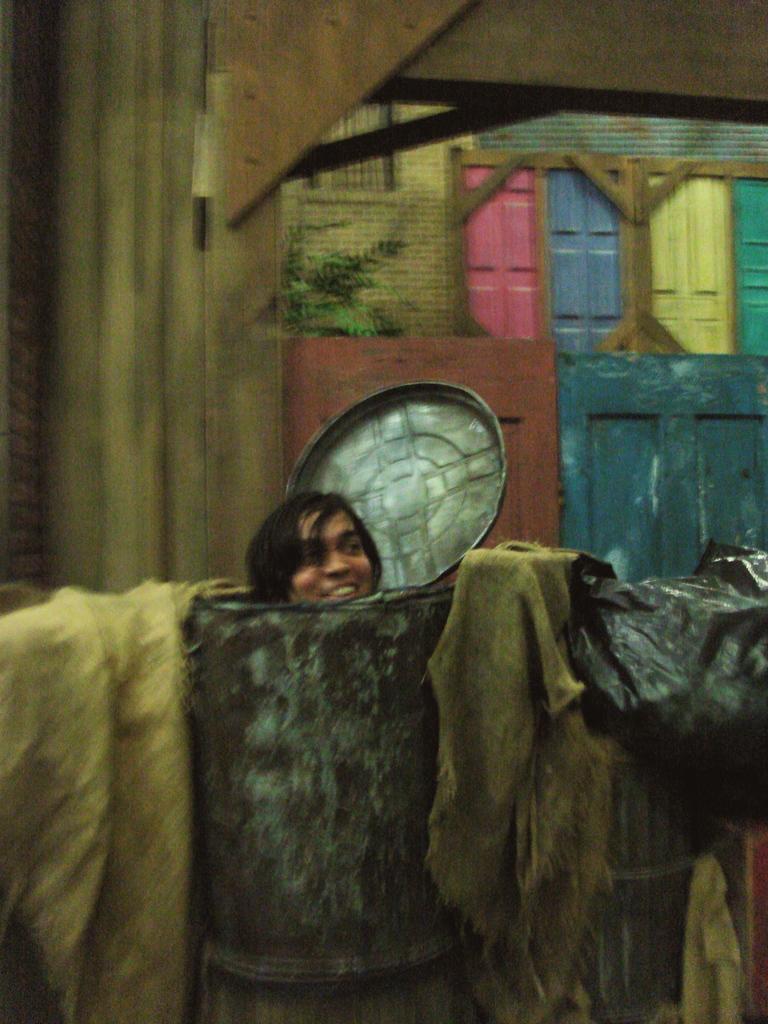Can you describe this image briefly? In the foreground I can see a person is standing in a barrel. In the background I can see a wall and windows. This image is taken in a room. 